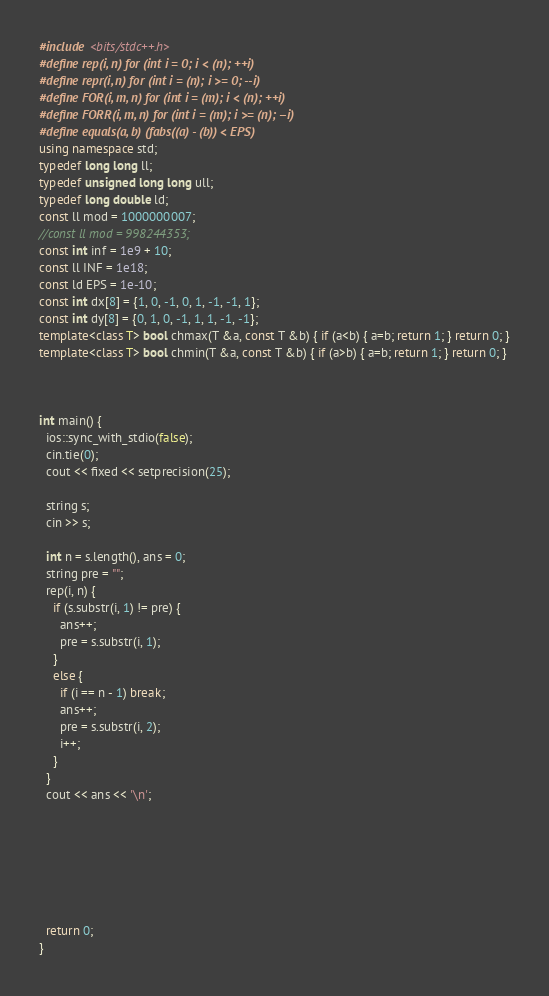Convert code to text. <code><loc_0><loc_0><loc_500><loc_500><_C++_>#include <bits/stdc++.h>
#define rep(i, n) for (int i = 0; i < (n); ++i)
#define repr(i, n) for (int i = (n); i >= 0; --i)
#define FOR(i, m, n) for (int i = (m); i < (n); ++i)
#define FORR(i, m, n) for (int i = (m); i >= (n); --i)
#define equals(a, b) (fabs((a) - (b)) < EPS)
using namespace std;
typedef long long ll;
typedef unsigned long long ull;
typedef long double ld;
const ll mod = 1000000007;
//const ll mod = 998244353;
const int inf = 1e9 + 10;
const ll INF = 1e18;
const ld EPS = 1e-10;
const int dx[8] = {1, 0, -1, 0, 1, -1, -1, 1};
const int dy[8] = {0, 1, 0, -1, 1, 1, -1, -1};
template<class T> bool chmax(T &a, const T &b) { if (a<b) { a=b; return 1; } return 0; }
template<class T> bool chmin(T &a, const T &b) { if (a>b) { a=b; return 1; } return 0; }



int main() {
  ios::sync_with_stdio(false);
  cin.tie(0);
  cout << fixed << setprecision(25);

  string s;
  cin >> s;

  int n = s.length(), ans = 0;
  string pre = "";
  rep(i, n) {
    if (s.substr(i, 1) != pre) {
      ans++;
      pre = s.substr(i, 1);
    }
    else {
      if (i == n - 1) break;
      ans++;
      pre = s.substr(i, 2);
      i++;
    }
  }
  cout << ans << '\n';

  




  
  return 0;
}</code> 